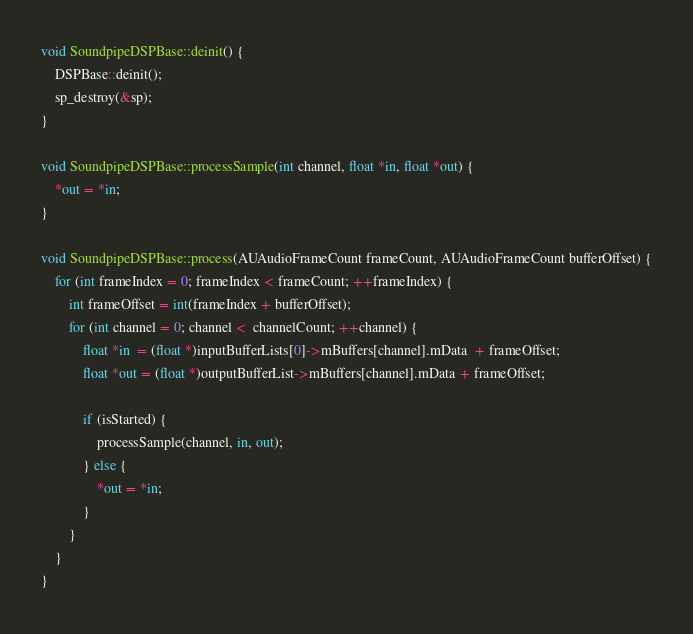<code> <loc_0><loc_0><loc_500><loc_500><_ObjectiveC_>void SoundpipeDSPBase::deinit() {
    DSPBase::deinit();
    sp_destroy(&sp);
}

void SoundpipeDSPBase::processSample(int channel, float *in, float *out) {
    *out = *in;
}

void SoundpipeDSPBase::process(AUAudioFrameCount frameCount, AUAudioFrameCount bufferOffset) {
    for (int frameIndex = 0; frameIndex < frameCount; ++frameIndex) {
        int frameOffset = int(frameIndex + bufferOffset);
        for (int channel = 0; channel <  channelCount; ++channel) {
            float *in  = (float *)inputBufferLists[0]->mBuffers[channel].mData  + frameOffset;
            float *out = (float *)outputBufferList->mBuffers[channel].mData + frameOffset;

            if (isStarted) {
                processSample(channel, in, out);
            } else {
                *out = *in;
            }
        }
    }
}
</code> 